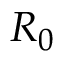Convert formula to latex. <formula><loc_0><loc_0><loc_500><loc_500>R _ { 0 }</formula> 